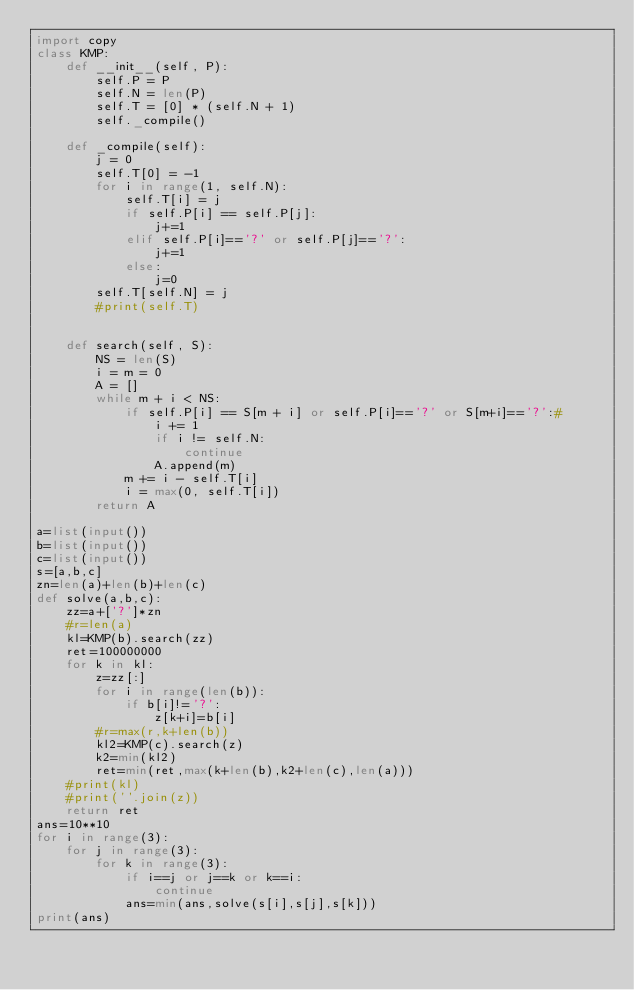<code> <loc_0><loc_0><loc_500><loc_500><_Python_>import copy
class KMP:
    def __init__(self, P):
        self.P = P
        self.N = len(P)
        self.T = [0] * (self.N + 1)
        self._compile()

    def _compile(self):
        j = 0
        self.T[0] = -1
        for i in range(1, self.N):
            self.T[i] = j
            if self.P[i] == self.P[j]:
                j+=1
            elif self.P[i]=='?' or self.P[j]=='?':
                j+=1
            else:
                j=0
        self.T[self.N] = j
        #print(self.T)
      

    def search(self, S):
        NS = len(S)
        i = m = 0
        A = []
        while m + i < NS:
            if self.P[i] == S[m + i] or self.P[i]=='?' or S[m+i]=='?':#
                i += 1
                if i != self.N:
                    continue
                A.append(m)
            m += i - self.T[i]
            i = max(0, self.T[i])
        return A

a=list(input())
b=list(input())
c=list(input())
s=[a,b,c]
zn=len(a)+len(b)+len(c)
def solve(a,b,c):
    zz=a+['?']*zn
    #r=len(a)
    kl=KMP(b).search(zz)
    ret=100000000
    for k in kl:
        z=zz[:] 
        for i in range(len(b)):
            if b[i]!='?':
                z[k+i]=b[i]
        #r=max(r,k+len(b))
        kl2=KMP(c).search(z)
        k2=min(kl2)
        ret=min(ret,max(k+len(b),k2+len(c),len(a)))
    #print(kl)
    #print(''.join(z))
    return ret
ans=10**10
for i in range(3):
    for j in range(3):
        for k in range(3):
            if i==j or j==k or k==i:
                continue
            ans=min(ans,solve(s[i],s[j],s[k]))
print(ans)
</code> 